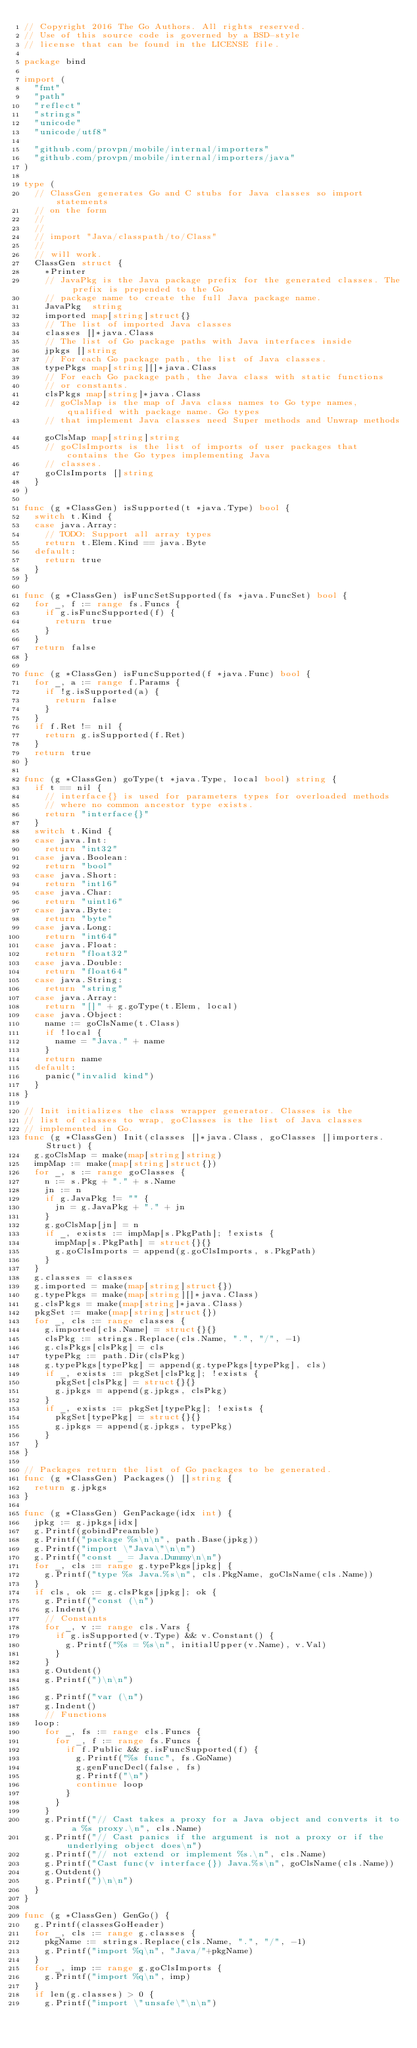Convert code to text. <code><loc_0><loc_0><loc_500><loc_500><_Go_>// Copyright 2016 The Go Authors. All rights reserved.
// Use of this source code is governed by a BSD-style
// license that can be found in the LICENSE file.

package bind

import (
	"fmt"
	"path"
	"reflect"
	"strings"
	"unicode"
	"unicode/utf8"

	"github.com/provpn/mobile/internal/importers"
	"github.com/provpn/mobile/internal/importers/java"
)

type (
	// ClassGen generates Go and C stubs for Java classes so import statements
	// on the form
	//
	//
	// import "Java/classpath/to/Class"
	//
	// will work.
	ClassGen struct {
		*Printer
		// JavaPkg is the Java package prefix for the generated classes. The prefix is prepended to the Go
		// package name to create the full Java package name.
		JavaPkg  string
		imported map[string]struct{}
		// The list of imported Java classes
		classes []*java.Class
		// The list of Go package paths with Java interfaces inside
		jpkgs []string
		// For each Go package path, the list of Java classes.
		typePkgs map[string][]*java.Class
		// For each Go package path, the Java class with static functions
		// or constants.
		clsPkgs map[string]*java.Class
		// goClsMap is the map of Java class names to Go type names, qualified with package name. Go types
		// that implement Java classes need Super methods and Unwrap methods.
		goClsMap map[string]string
		// goClsImports is the list of imports of user packages that contains the Go types implementing Java
		// classes.
		goClsImports []string
	}
)

func (g *ClassGen) isSupported(t *java.Type) bool {
	switch t.Kind {
	case java.Array:
		// TODO: Support all array types
		return t.Elem.Kind == java.Byte
	default:
		return true
	}
}

func (g *ClassGen) isFuncSetSupported(fs *java.FuncSet) bool {
	for _, f := range fs.Funcs {
		if g.isFuncSupported(f) {
			return true
		}
	}
	return false
}

func (g *ClassGen) isFuncSupported(f *java.Func) bool {
	for _, a := range f.Params {
		if !g.isSupported(a) {
			return false
		}
	}
	if f.Ret != nil {
		return g.isSupported(f.Ret)
	}
	return true
}

func (g *ClassGen) goType(t *java.Type, local bool) string {
	if t == nil {
		// interface{} is used for parameters types for overloaded methods
		// where no common ancestor type exists.
		return "interface{}"
	}
	switch t.Kind {
	case java.Int:
		return "int32"
	case java.Boolean:
		return "bool"
	case java.Short:
		return "int16"
	case java.Char:
		return "uint16"
	case java.Byte:
		return "byte"
	case java.Long:
		return "int64"
	case java.Float:
		return "float32"
	case java.Double:
		return "float64"
	case java.String:
		return "string"
	case java.Array:
		return "[]" + g.goType(t.Elem, local)
	case java.Object:
		name := goClsName(t.Class)
		if !local {
			name = "Java." + name
		}
		return name
	default:
		panic("invalid kind")
	}
}

// Init initializes the class wrapper generator. Classes is the
// list of classes to wrap, goClasses is the list of Java classes
// implemented in Go.
func (g *ClassGen) Init(classes []*java.Class, goClasses []importers.Struct) {
	g.goClsMap = make(map[string]string)
	impMap := make(map[string]struct{})
	for _, s := range goClasses {
		n := s.Pkg + "." + s.Name
		jn := n
		if g.JavaPkg != "" {
			jn = g.JavaPkg + "." + jn
		}
		g.goClsMap[jn] = n
		if _, exists := impMap[s.PkgPath]; !exists {
			impMap[s.PkgPath] = struct{}{}
			g.goClsImports = append(g.goClsImports, s.PkgPath)
		}
	}
	g.classes = classes
	g.imported = make(map[string]struct{})
	g.typePkgs = make(map[string][]*java.Class)
	g.clsPkgs = make(map[string]*java.Class)
	pkgSet := make(map[string]struct{})
	for _, cls := range classes {
		g.imported[cls.Name] = struct{}{}
		clsPkg := strings.Replace(cls.Name, ".", "/", -1)
		g.clsPkgs[clsPkg] = cls
		typePkg := path.Dir(clsPkg)
		g.typePkgs[typePkg] = append(g.typePkgs[typePkg], cls)
		if _, exists := pkgSet[clsPkg]; !exists {
			pkgSet[clsPkg] = struct{}{}
			g.jpkgs = append(g.jpkgs, clsPkg)
		}
		if _, exists := pkgSet[typePkg]; !exists {
			pkgSet[typePkg] = struct{}{}
			g.jpkgs = append(g.jpkgs, typePkg)
		}
	}
}

// Packages return the list of Go packages to be generated.
func (g *ClassGen) Packages() []string {
	return g.jpkgs
}

func (g *ClassGen) GenPackage(idx int) {
	jpkg := g.jpkgs[idx]
	g.Printf(gobindPreamble)
	g.Printf("package %s\n\n", path.Base(jpkg))
	g.Printf("import \"Java\"\n\n")
	g.Printf("const _ = Java.Dummy\n\n")
	for _, cls := range g.typePkgs[jpkg] {
		g.Printf("type %s Java.%s\n", cls.PkgName, goClsName(cls.Name))
	}
	if cls, ok := g.clsPkgs[jpkg]; ok {
		g.Printf("const (\n")
		g.Indent()
		// Constants
		for _, v := range cls.Vars {
			if g.isSupported(v.Type) && v.Constant() {
				g.Printf("%s = %s\n", initialUpper(v.Name), v.Val)
			}
		}
		g.Outdent()
		g.Printf(")\n\n")

		g.Printf("var (\n")
		g.Indent()
		// Functions
	loop:
		for _, fs := range cls.Funcs {
			for _, f := range fs.Funcs {
				if f.Public && g.isFuncSupported(f) {
					g.Printf("%s func", fs.GoName)
					g.genFuncDecl(false, fs)
					g.Printf("\n")
					continue loop
				}
			}
		}
		g.Printf("// Cast takes a proxy for a Java object and converts it to a %s proxy.\n", cls.Name)
		g.Printf("// Cast panics if the argument is not a proxy or if the underlying object does\n")
		g.Printf("// not extend or implement %s.\n", cls.Name)
		g.Printf("Cast func(v interface{}) Java.%s\n", goClsName(cls.Name))
		g.Outdent()
		g.Printf(")\n\n")
	}
}

func (g *ClassGen) GenGo() {
	g.Printf(classesGoHeader)
	for _, cls := range g.classes {
		pkgName := strings.Replace(cls.Name, ".", "/", -1)
		g.Printf("import %q\n", "Java/"+pkgName)
	}
	for _, imp := range g.goClsImports {
		g.Printf("import %q\n", imp)
	}
	if len(g.classes) > 0 {
		g.Printf("import \"unsafe\"\n\n")</code> 